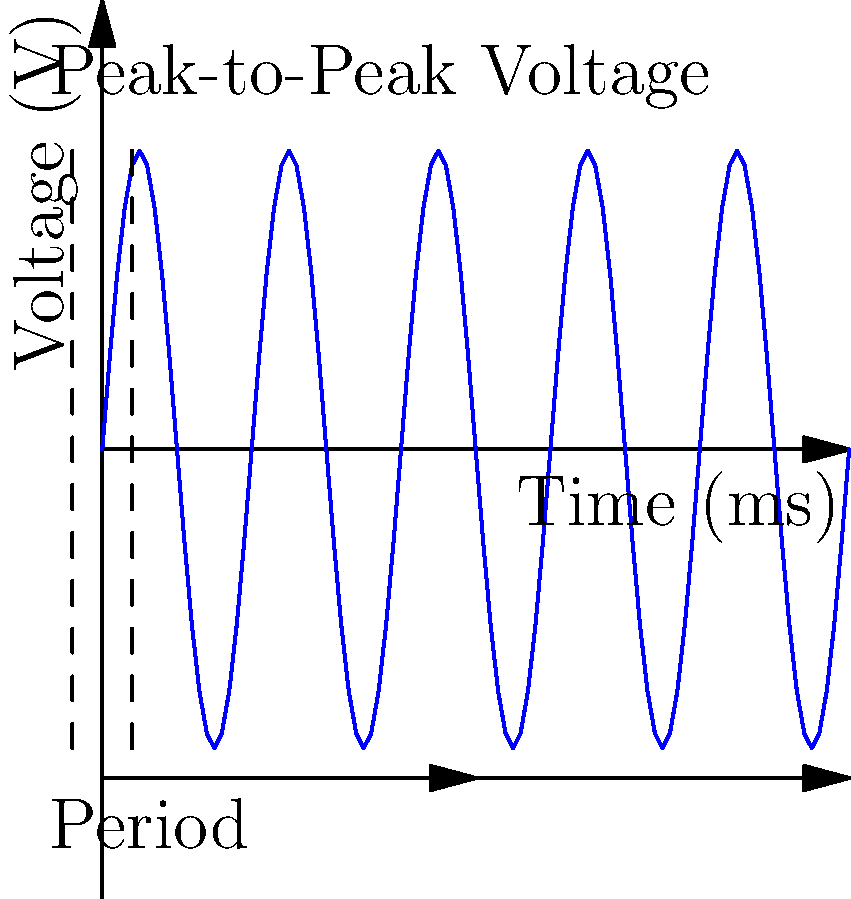As an emotionally invested player in the world of electrical engineering, you're tasked with analyzing a crucial waveform that could impact your character's journey. Examine the oscilloscope display of an alternating current signal shown above. What is the frequency of this signal? Let's approach this step-by-step, imagining how your character might tackle this challenge:

1) First, we need to determine the period (T) of the waveform. The period is the time it takes for one complete cycle of the wave.

2) From the graph, we can see that one complete cycle takes 2.5 ms (milliseconds). This is indicated by the arrows labeled "Period" at the bottom of the graph.

3) The relationship between frequency (f) and period (T) is given by the equation:

   $f = \frac{1}{T}$

4) We know T = 2.5 ms = 0.0025 s (converting to seconds)

5) Plugging this into our equation:

   $f = \frac{1}{0.0025\text{ s}} = 400\text{ Hz}$

6) Therefore, the frequency of the signal is 400 Hz.

Remember, in the world of your character, understanding these waveforms could be the key to unraveling mysteries or overcoming obstacles in their electrical engineering adventures!
Answer: 400 Hz 